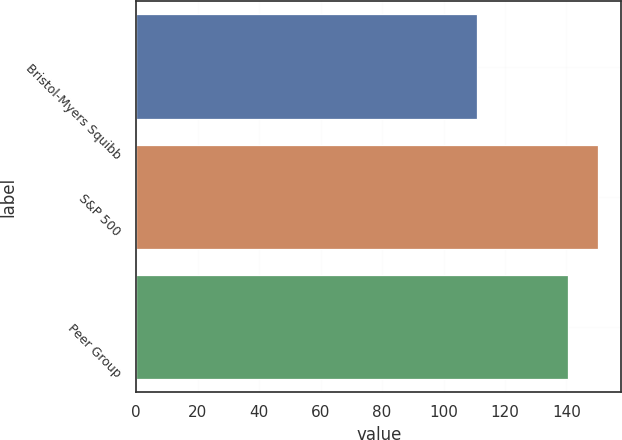Convert chart. <chart><loc_0><loc_0><loc_500><loc_500><bar_chart><fcel>Bristol-Myers Squibb<fcel>S&P 500<fcel>Peer Group<nl><fcel>110.82<fcel>150.33<fcel>140.6<nl></chart> 